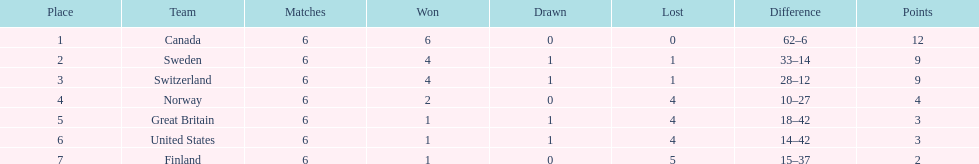In the 1951 world ice hockey championships, which nation had a better performance: switzerland or great britain? Switzerland. 